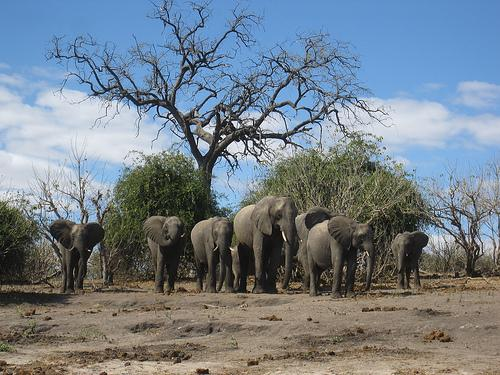State the primary components of the scene and the weather conditions. Group of gray elephants, trees with and without leaves, and blue sky with clouds are the main components, under clear and sunny weather. Describe the actions of the animals and their surroundings using present tense verbs. Elephants stand and walk on a dirt field, with patches of grass surrounding them, while trees frame the area, and white clouds drift through the blue sky above. Write a concise summary of the image, highlighting the main features. The image showcases a group of elephants in a field with dry grass, surrounded by bare and green trees, under a cloudy blue sky. Mention the focal point of the image and discuss the scenery around it. The focal point is a herd of elephants on a dirt field; the surrounding scenery includes leafless and leafy trees, and a bright blue sky with white clouds. Give a brief description of the image contents, focusing on the main elements. A herd of elephants is walking on a dirt field with a large dead tree and green trees in the background, under a blue sky with white clouds. Mention the primary subject of the image and the weather. A group of elephants is the main subject, with a clear sunny blue sky and white fluffy clouds overhead. Describe the animals in the image and their environment. Six gray elephants move across a dusty dirt ground with patches of grass, surrounded by bare and leaf-filled trees, beneath a cloudy blue sky. Write a short story about the image, focusing on the main subjects. Once upon a time, a herd of grey elephants wandered together in a field with dry grass, under the watchful eyes of leafless and green-leafed trees, as white fluffy clouds decorated the sky. Provide a vivid description of the image, focusing on the atmosphere. A lively scene unfolds as a pack of elephants walks on a dusty barren field, framed by a mix of lively green and skeletal trees, under the vast expanse of a blue sky adorned with puffy white clouds. State the primary colors found in the image and their context. Gray is the color of the group of elephants, green for the trees filled with leaves, and blue for the beautiful sky accompanied by white clouds. 